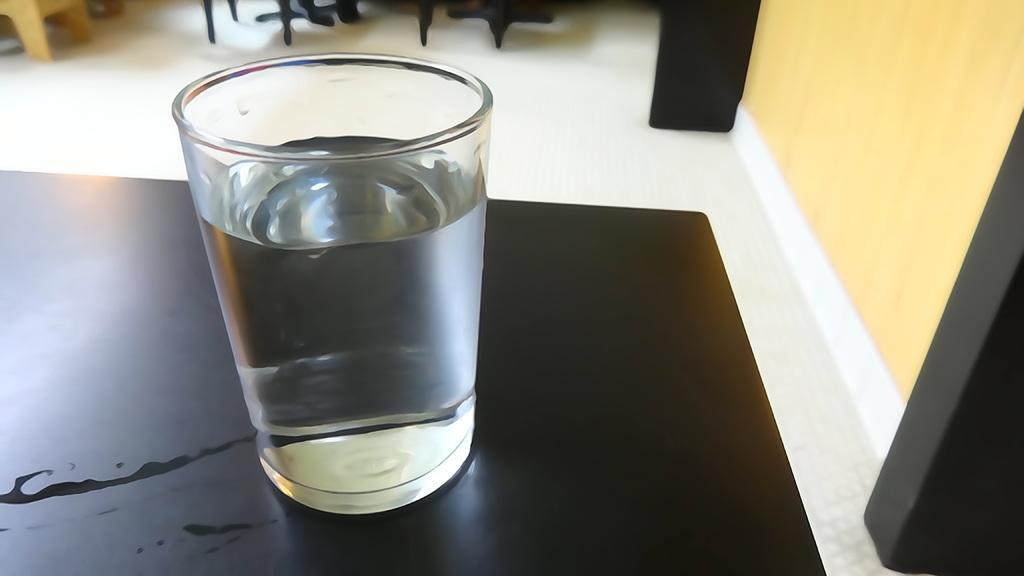What piece of furniture is present in the image? There is a table in the image. Where is the table located in relation to the other elements in the image? The table is located towards the left side. What is on the table in the image? There is a glass full of water on the table. What type of structure can be seen in the image? There is a wall and two pillars in the image. Where are the wall and pillars located in the image? The wall and pillars are located towards the right side. Can you see any fairies smiling near the glass of water in the image? There are no fairies or smiles present in the image. 